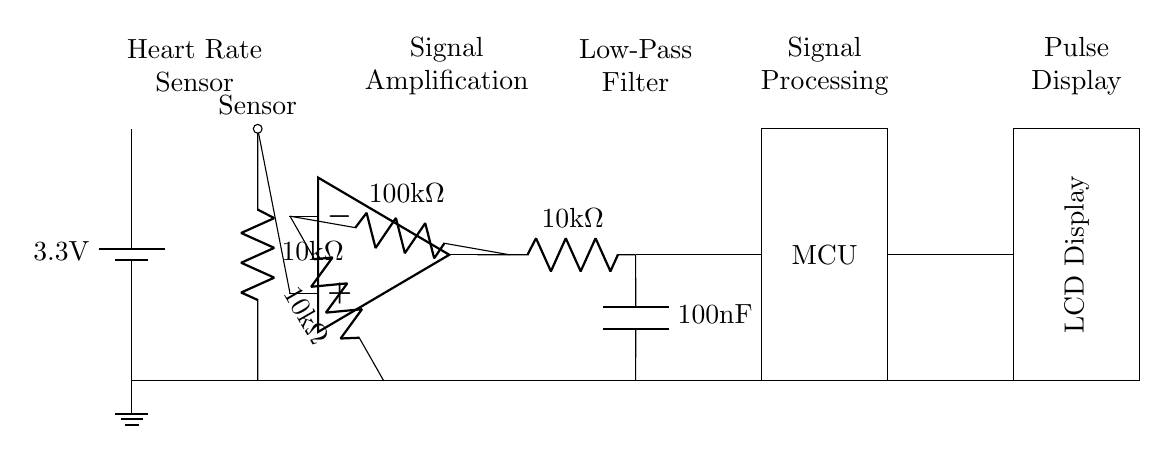What is the voltage supplied to the circuit? The circuit is powered by a battery, labeled with a voltage of 3.3 volts, which is the power supply for the entire circuit.
Answer: 3.3 volts What component amplifies the sensor signal? The op-amp symbol in the diagram indicates it is used as an amplifier for the signal coming from the heart rate sensor.
Answer: Op-amp What is the resistance value after the amplifier? After the amplifier, there is a resistor labeled with a value of 100,000 ohms, which helps set the gain of the amplifier circuit.
Answer: 100 kΩ What purpose does the low-pass filter serve in the circuit? The low-pass filter, consisting of a resistor and a capacitor, smooths out the signal by dampening higher frequency noise, allowing only the desired lower frequency signals to pass through.
Answer: Smoothing What is the total resistance in series with the sensor? The sensor has a 10,000 ohm resistor directly in series, so the total resistance in that part of the circuit is 10,000 ohms.
Answer: 10 kΩ How is the processed signal displayed to the user? The processed signal is transmitted to an LCD display, which visually presents the heart rate information for the user to see during workouts.
Answer: LCD Display 